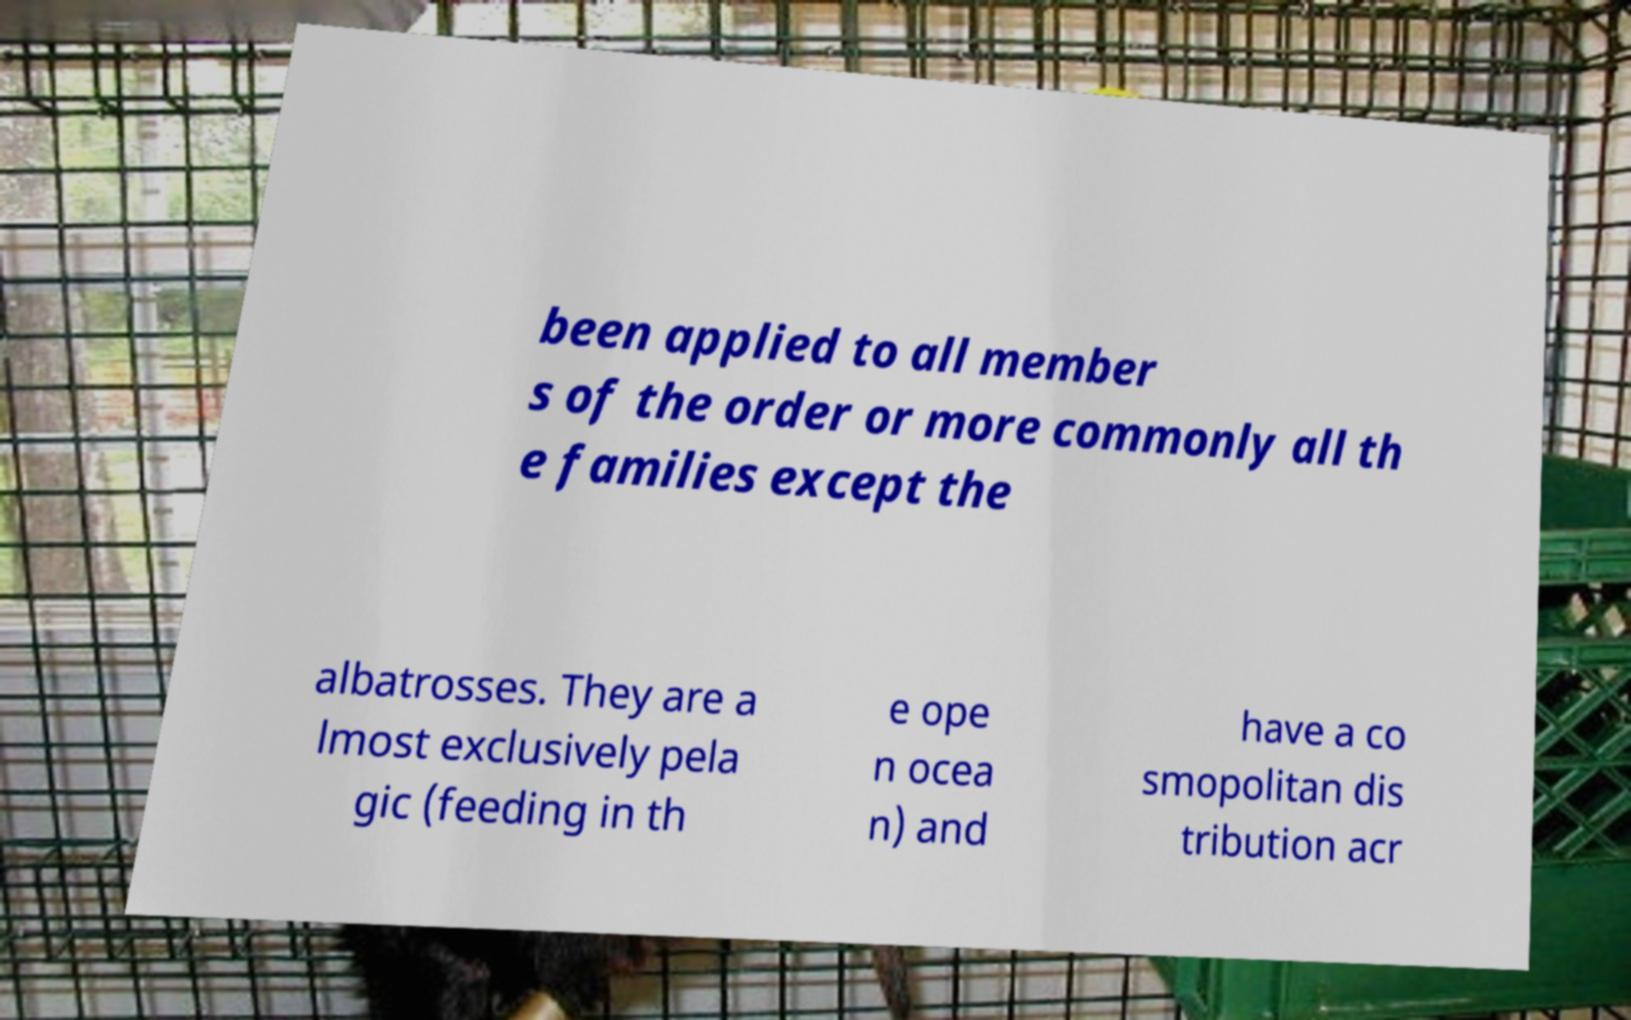Could you extract and type out the text from this image? been applied to all member s of the order or more commonly all th e families except the albatrosses. They are a lmost exclusively pela gic (feeding in th e ope n ocea n) and have a co smopolitan dis tribution acr 